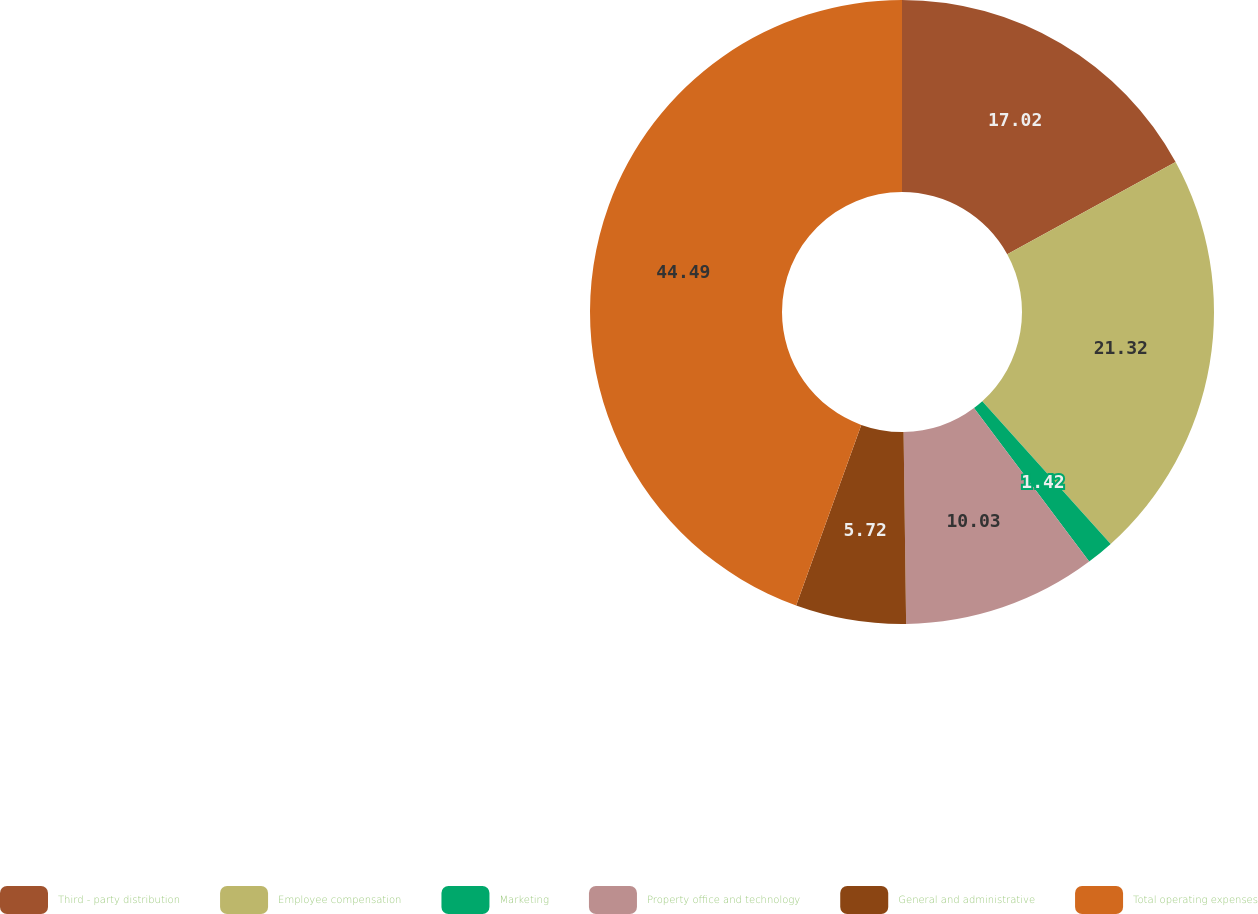Convert chart to OTSL. <chart><loc_0><loc_0><loc_500><loc_500><pie_chart><fcel>Third - party distribution<fcel>Employee compensation<fcel>Marketing<fcel>Property office and technology<fcel>General and administrative<fcel>Total operating expenses<nl><fcel>17.02%<fcel>21.32%<fcel>1.42%<fcel>10.03%<fcel>5.72%<fcel>44.49%<nl></chart> 